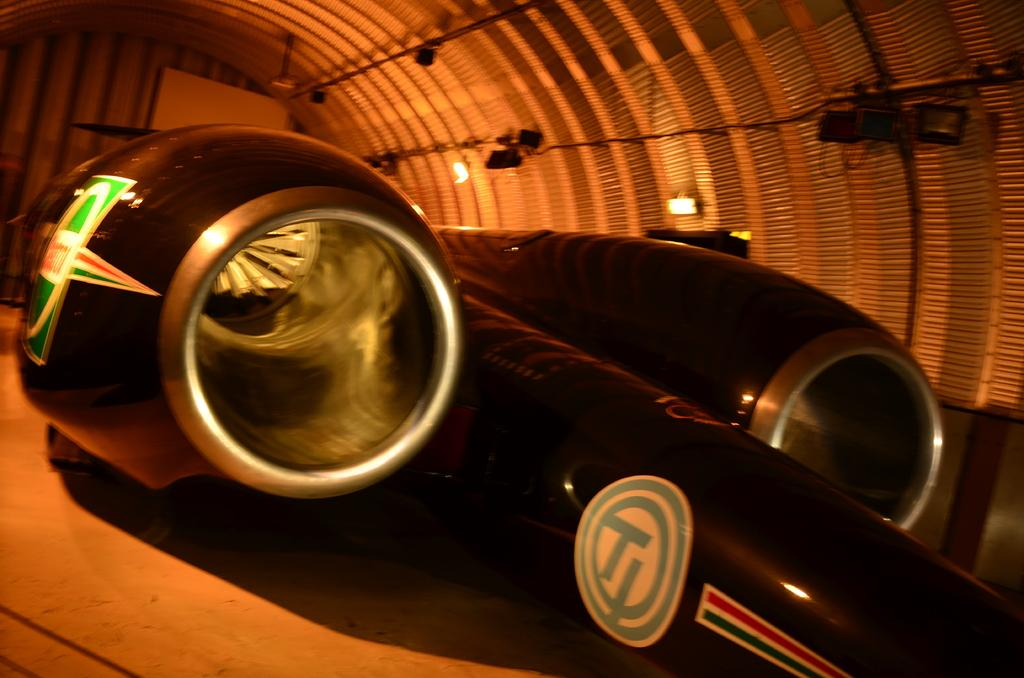What is the main subject of the image? The main subject of the image is an aircraft. Are there any distinguishing features on the aircraft? Yes, the aircraft has logos. What can be seen in the background of the image? There are lights and other objects visible in the background of the image. How many twigs are hanging from the aircraft in the image? There are no twigs present in the image; the main subject is an aircraft with logos. What type of spiders can be seen crawling on the aircraft in the image? There are no spiders present in the image; the main subject is an aircraft with logos. 